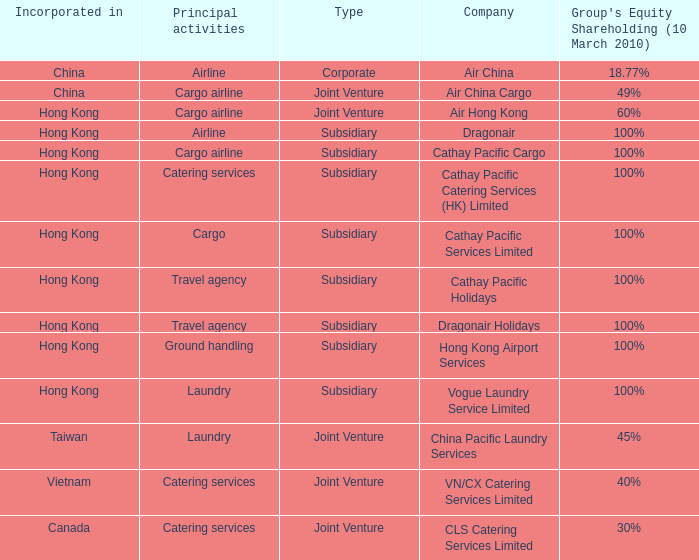Would you mind parsing the complete table? {'header': ['Incorporated in', 'Principal activities', 'Type', 'Company', "Group's Equity Shareholding (10 March 2010)"], 'rows': [['China', 'Airline', 'Corporate', 'Air China', '18.77%'], ['China', 'Cargo airline', 'Joint Venture', 'Air China Cargo', '49%'], ['Hong Kong', 'Cargo airline', 'Joint Venture', 'Air Hong Kong', '60%'], ['Hong Kong', 'Airline', 'Subsidiary', 'Dragonair', '100%'], ['Hong Kong', 'Cargo airline', 'Subsidiary', 'Cathay Pacific Cargo', '100%'], ['Hong Kong', 'Catering services', 'Subsidiary', 'Cathay Pacific Catering Services (HK) Limited', '100%'], ['Hong Kong', 'Cargo', 'Subsidiary', 'Cathay Pacific Services Limited', '100%'], ['Hong Kong', 'Travel agency', 'Subsidiary', 'Cathay Pacific Holidays', '100%'], ['Hong Kong', 'Travel agency', 'Subsidiary', 'Dragonair Holidays', '100%'], ['Hong Kong', 'Ground handling', 'Subsidiary', 'Hong Kong Airport Services', '100%'], ['Hong Kong', 'Laundry', 'Subsidiary', 'Vogue Laundry Service Limited', '100%'], ['Taiwan', 'Laundry', 'Joint Venture', 'China Pacific Laundry Services', '45%'], ['Vietnam', 'Catering services', 'Joint Venture', 'VN/CX Catering Services Limited', '40%'], ['Canada', 'Catering services', 'Joint Venture', 'CLS Catering Services Limited', '30%']]} What is the name of the company that has a Group's equity shareholding percentage, as of March 10th, 2010, of 100%, as well as a Principal activity of Airline? Dragonair. 